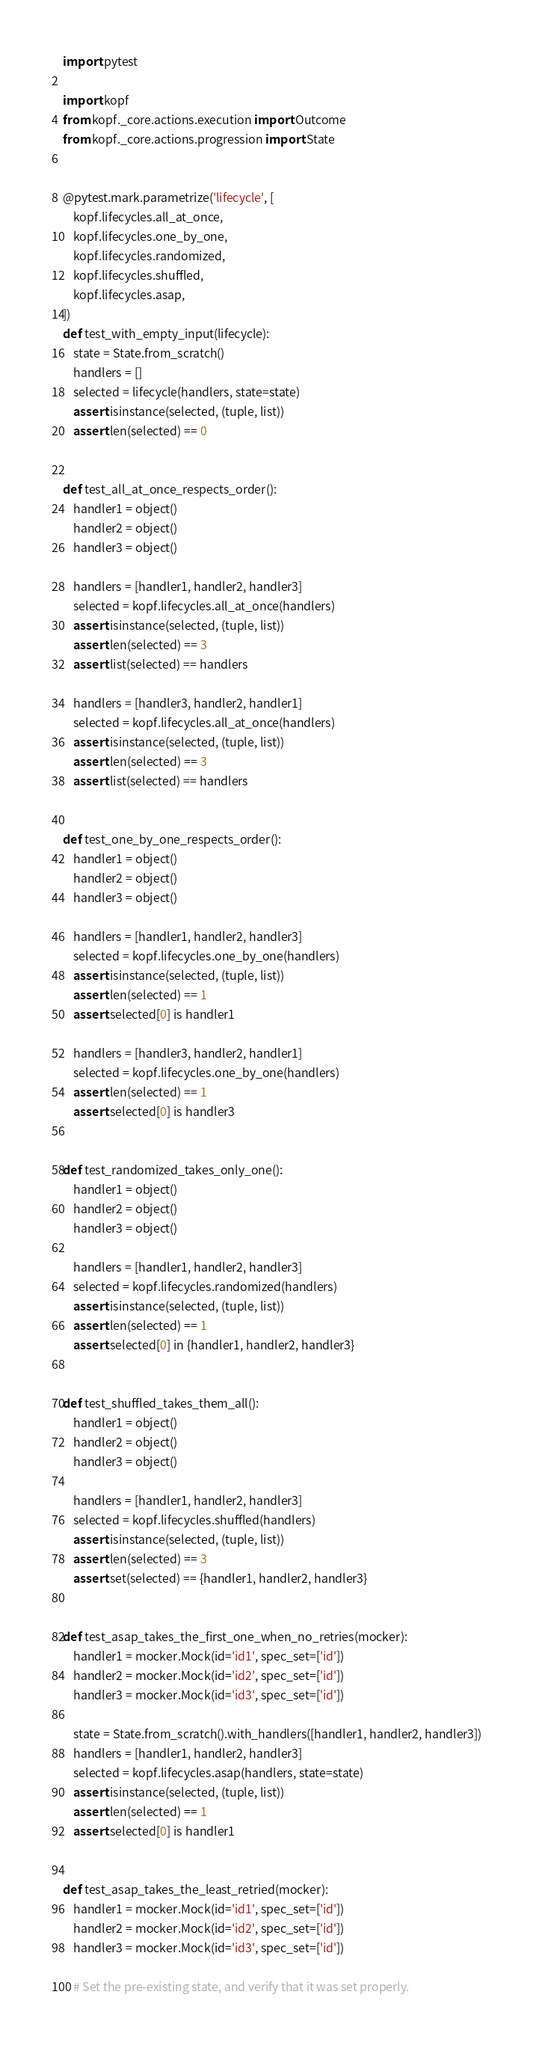<code> <loc_0><loc_0><loc_500><loc_500><_Python_>import pytest

import kopf
from kopf._core.actions.execution import Outcome
from kopf._core.actions.progression import State


@pytest.mark.parametrize('lifecycle', [
    kopf.lifecycles.all_at_once,
    kopf.lifecycles.one_by_one,
    kopf.lifecycles.randomized,
    kopf.lifecycles.shuffled,
    kopf.lifecycles.asap,
])
def test_with_empty_input(lifecycle):
    state = State.from_scratch()
    handlers = []
    selected = lifecycle(handlers, state=state)
    assert isinstance(selected, (tuple, list))
    assert len(selected) == 0


def test_all_at_once_respects_order():
    handler1 = object()
    handler2 = object()
    handler3 = object()

    handlers = [handler1, handler2, handler3]
    selected = kopf.lifecycles.all_at_once(handlers)
    assert isinstance(selected, (tuple, list))
    assert len(selected) == 3
    assert list(selected) == handlers

    handlers = [handler3, handler2, handler1]
    selected = kopf.lifecycles.all_at_once(handlers)
    assert isinstance(selected, (tuple, list))
    assert len(selected) == 3
    assert list(selected) == handlers


def test_one_by_one_respects_order():
    handler1 = object()
    handler2 = object()
    handler3 = object()

    handlers = [handler1, handler2, handler3]
    selected = kopf.lifecycles.one_by_one(handlers)
    assert isinstance(selected, (tuple, list))
    assert len(selected) == 1
    assert selected[0] is handler1

    handlers = [handler3, handler2, handler1]
    selected = kopf.lifecycles.one_by_one(handlers)
    assert len(selected) == 1
    assert selected[0] is handler3


def test_randomized_takes_only_one():
    handler1 = object()
    handler2 = object()
    handler3 = object()

    handlers = [handler1, handler2, handler3]
    selected = kopf.lifecycles.randomized(handlers)
    assert isinstance(selected, (tuple, list))
    assert len(selected) == 1
    assert selected[0] in {handler1, handler2, handler3}


def test_shuffled_takes_them_all():
    handler1 = object()
    handler2 = object()
    handler3 = object()

    handlers = [handler1, handler2, handler3]
    selected = kopf.lifecycles.shuffled(handlers)
    assert isinstance(selected, (tuple, list))
    assert len(selected) == 3
    assert set(selected) == {handler1, handler2, handler3}


def test_asap_takes_the_first_one_when_no_retries(mocker):
    handler1 = mocker.Mock(id='id1', spec_set=['id'])
    handler2 = mocker.Mock(id='id2', spec_set=['id'])
    handler3 = mocker.Mock(id='id3', spec_set=['id'])

    state = State.from_scratch().with_handlers([handler1, handler2, handler3])
    handlers = [handler1, handler2, handler3]
    selected = kopf.lifecycles.asap(handlers, state=state)
    assert isinstance(selected, (tuple, list))
    assert len(selected) == 1
    assert selected[0] is handler1


def test_asap_takes_the_least_retried(mocker):
    handler1 = mocker.Mock(id='id1', spec_set=['id'])
    handler2 = mocker.Mock(id='id2', spec_set=['id'])
    handler3 = mocker.Mock(id='id3', spec_set=['id'])

    # Set the pre-existing state, and verify that it was set properly.</code> 